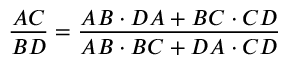<formula> <loc_0><loc_0><loc_500><loc_500>{ \frac { A C } { B D } } = { \frac { A B \cdot D A + B C \cdot C D } { A B \cdot B C + D A \cdot C D } }</formula> 